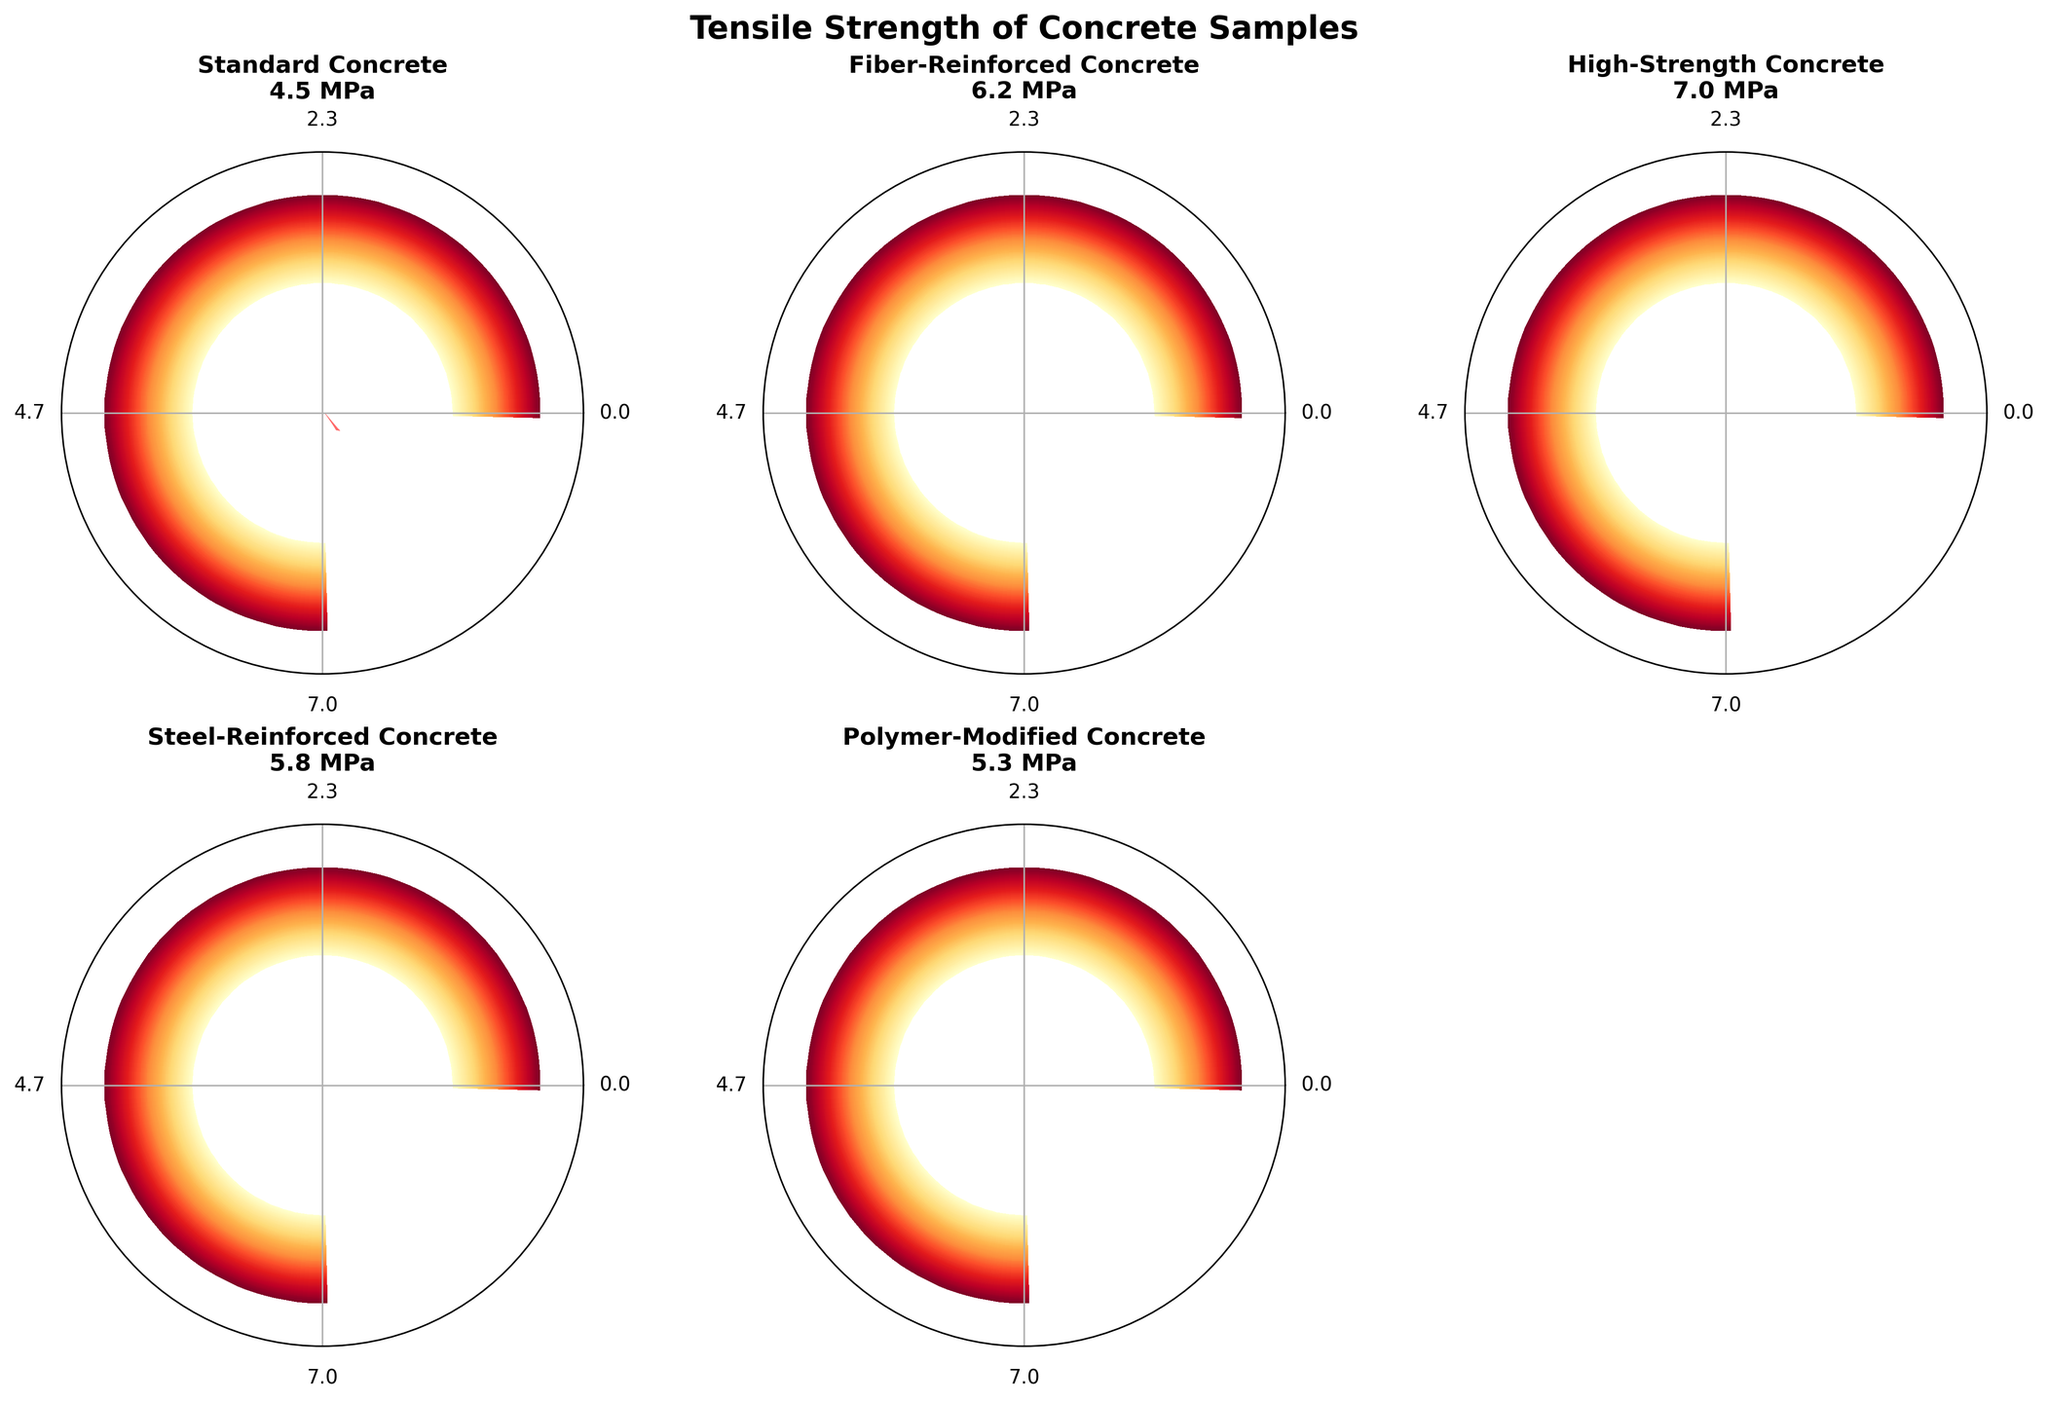What is the title of the figure? The title is usually located at the top of the figure. In this case, it reads "Tensile Strength of Concrete Samples".
Answer: Tensile Strength of Concrete Samples What is the tensile strength of High-Strength Concrete? According to the chart, the tensile strength value for High-Strength Concrete is displayed in the chart’s title for that particular gauge and it reads "7.0 MPa".
Answer: 7.0 MPa Which type of concrete has the lowest tensile strength? By comparing the needle positions and the labels on each gauge, the Standard Concrete gauge has the lowest needle position at "4.5 MPa".
Answer: Standard Concrete How many types of concrete samples are shown? There are 5 gauge charts each representing a different type of concrete sample, including Standard Concrete, Fiber-Reinforced Concrete, High-Strength Concrete, Steel-Reinforced Concrete, and Polymer-Modified Concrete.
Answer: 5 What is the median tensile strength value among all the concrete samples? Arranging the tensile strengths in ascending order: 4.5, 5.3, 5.8, 6.2, 7.0. The middle value (median) in this ordered list is 5.8 MPa, which is the tensile strength of Steel-Reinforced Concrete.
Answer: 5.8 MPa How does the tensile strength of Polymer-Modified Concrete compare to that of Steel-Reinforced Concrete? The tensile strength for Polymer-Modified Concrete is 5.3 MPa and for Steel-Reinforced Concrete is 5.8 MPa. 5.3 MPa is less than 5.8 MPa.
Answer: Polymer-Modified Concrete is less than Steel-Reinforced Concrete Which type of concrete has a tensile strength of 6.2 MPa? By looking at the gauges, Fiber-Reinforced Concrete shows a tensile strength of 6.2 MPa.
Answer: Fiber-Reinforced Concrete What is the range of tensile strengths displayed on each gauge? Each gauge displays a range from 0 MPa to 7 MPa as indicated by the ticks on the gauges.
Answer: 0 to 7 MPa How much higher is the tensile strength of High-Strength Concrete compared to Standard Concrete? High-Strength Concrete has a tensile strength of 7.0 MPa, and Standard Concrete has 4.5 MPa. The difference is 7.0 - 4.5 = 2.5 MPa.
Answer: 2.5 MPa On which type of concrete is the needle closest to the maximum value of the gauge? The gauge for High-Strength Concrete is closest to the maximum value as it reads 7.0 MPa, which is at the upper limit of the range.
Answer: High-Strength Concrete 